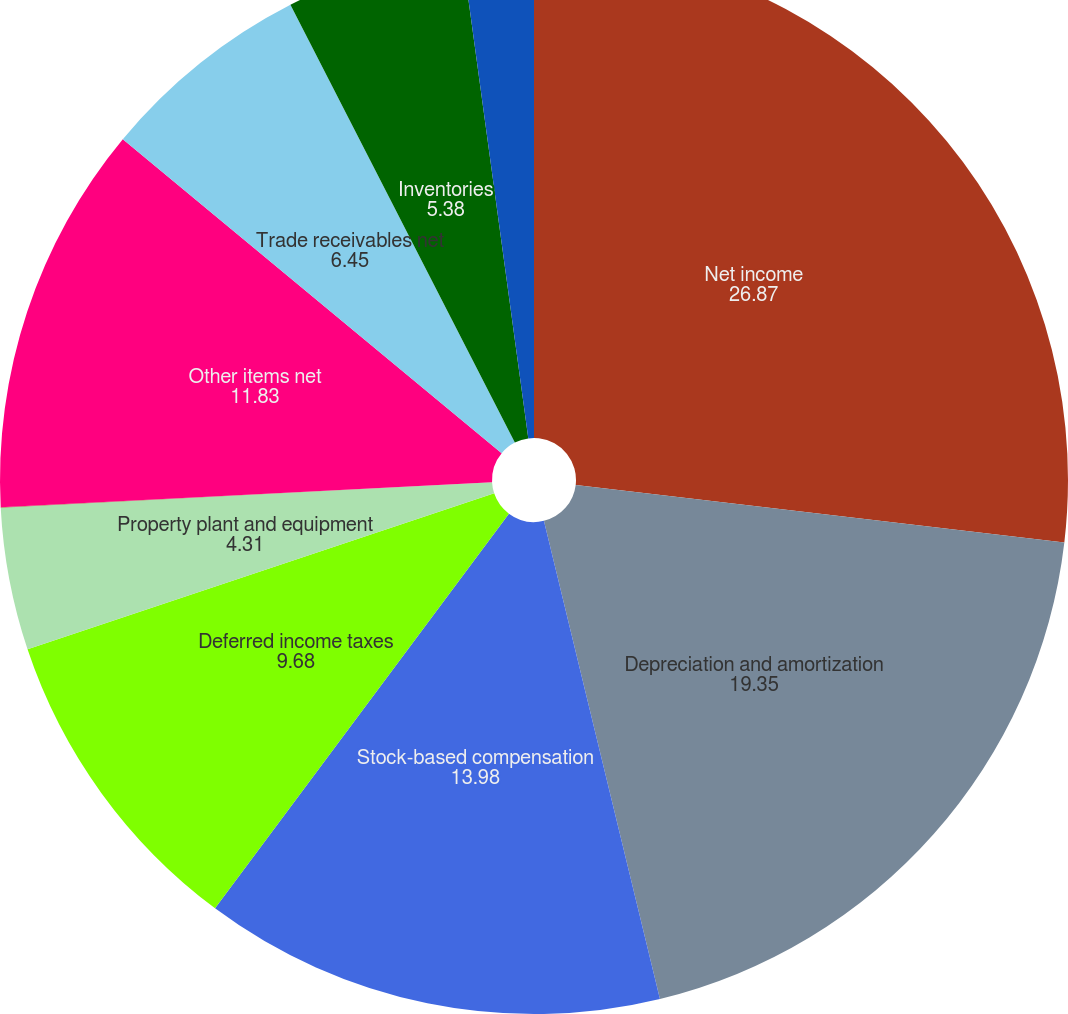<chart> <loc_0><loc_0><loc_500><loc_500><pie_chart><fcel>Net income<fcel>Depreciation and amortization<fcel>Stock-based compensation<fcel>Deferred income taxes<fcel>Property plant and equipment<fcel>Dividend received from equity<fcel>Other items net<fcel>Trade receivables net<fcel>Inventories<fcel>Other current assets<nl><fcel>26.87%<fcel>19.35%<fcel>13.98%<fcel>9.68%<fcel>4.31%<fcel>0.01%<fcel>11.83%<fcel>6.45%<fcel>5.38%<fcel>2.16%<nl></chart> 